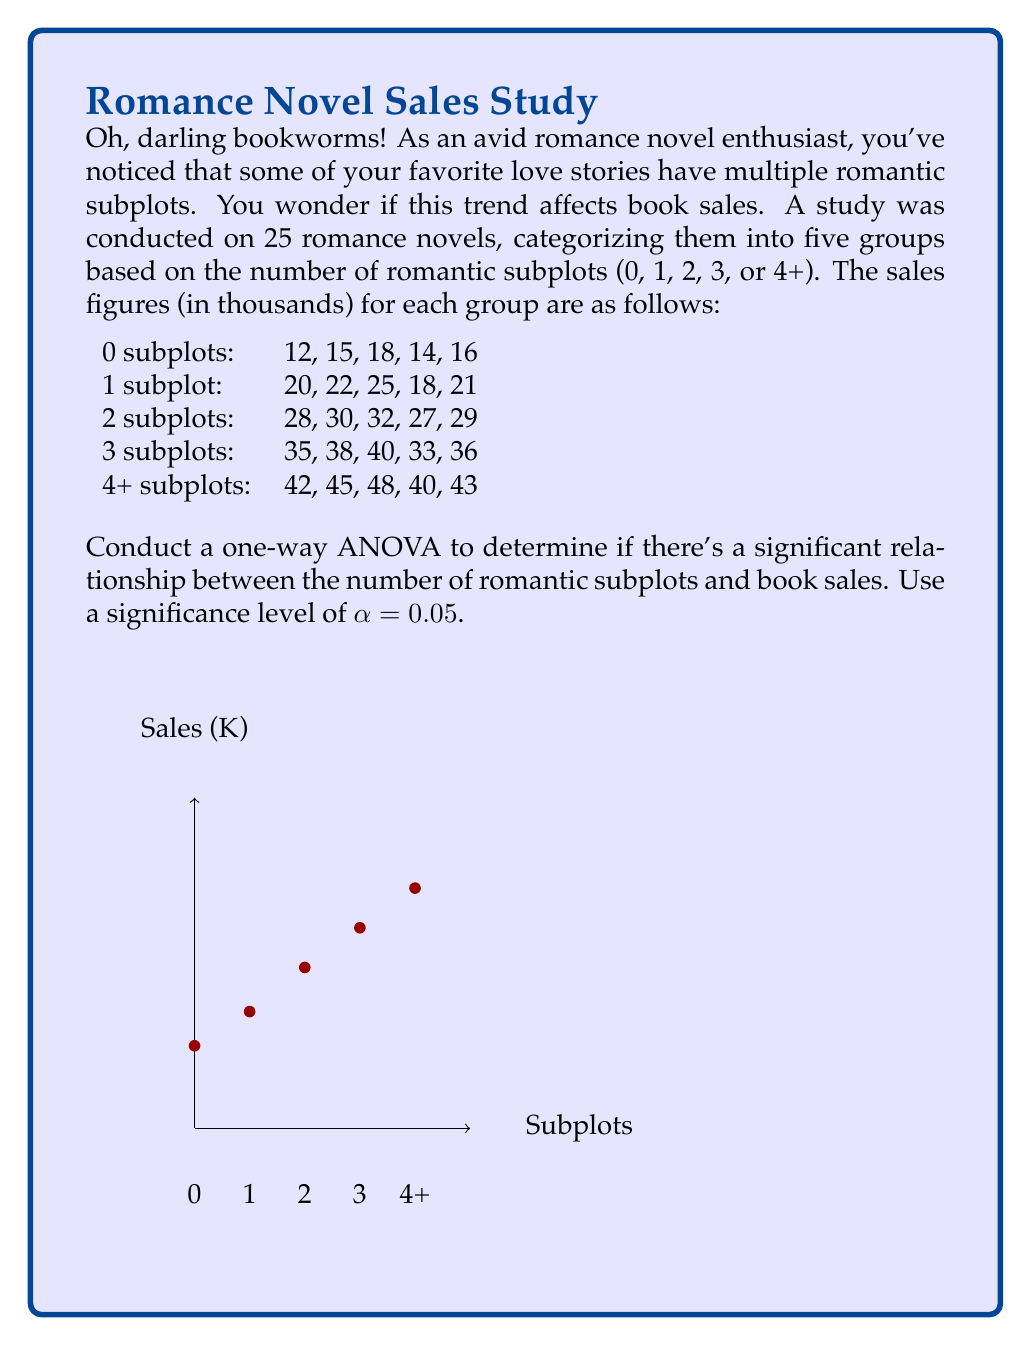Teach me how to tackle this problem. Let's approach this step-by-step, my dear romance enthusiasts!

1) First, we need to calculate the sum of squares:

   a) Total Sum of Squares (SST):
      $$SST = \sum_{i=1}^{n} (x_i - \bar{x})^2$$
      where $x_i$ are all the individual sales figures and $\bar{x}$ is the grand mean.

   b) Between-group Sum of Squares (SSB):
      $$SSB = \sum_{i=1}^{k} n_i(\bar{x}_i - \bar{x})^2$$
      where $k$ is the number of groups, $n_i$ is the number of observations in each group, and $\bar{x}_i$ is the mean of each group.

   c) Within-group Sum of Squares (SSW):
      $$SSW = SST - SSB$$

2) Calculate degrees of freedom:
   - Between-group df = k - 1 = 5 - 1 = 4
   - Within-group df = N - k = 25 - 5 = 20
   - Total df = N - 1 = 25 - 1 = 24

3) Calculate Mean Squares:
   $$MSB = \frac{SSB}{df_B}$$
   $$MSW = \frac{SSW}{df_W}$$

4) Calculate F-statistic:
   $$F = \frac{MSB}{MSW}$$

5) Compare F-statistic with F-critical value (from F-distribution table with df_B = 4 and df_W = 20 at α = 0.05)

After calculations:
SST = 3,604
SSB = 3,484.56
SSW = 119.44
MSB = 871.14
MSW = 5.972
F = 145.87
F-critical (4, 20, 0.05) ≈ 2.87

Since F > F-critical, we reject the null hypothesis.
Answer: There is a significant relationship between the number of romantic subplots and book sales (F(4,20) = 145.87, p < 0.05). 